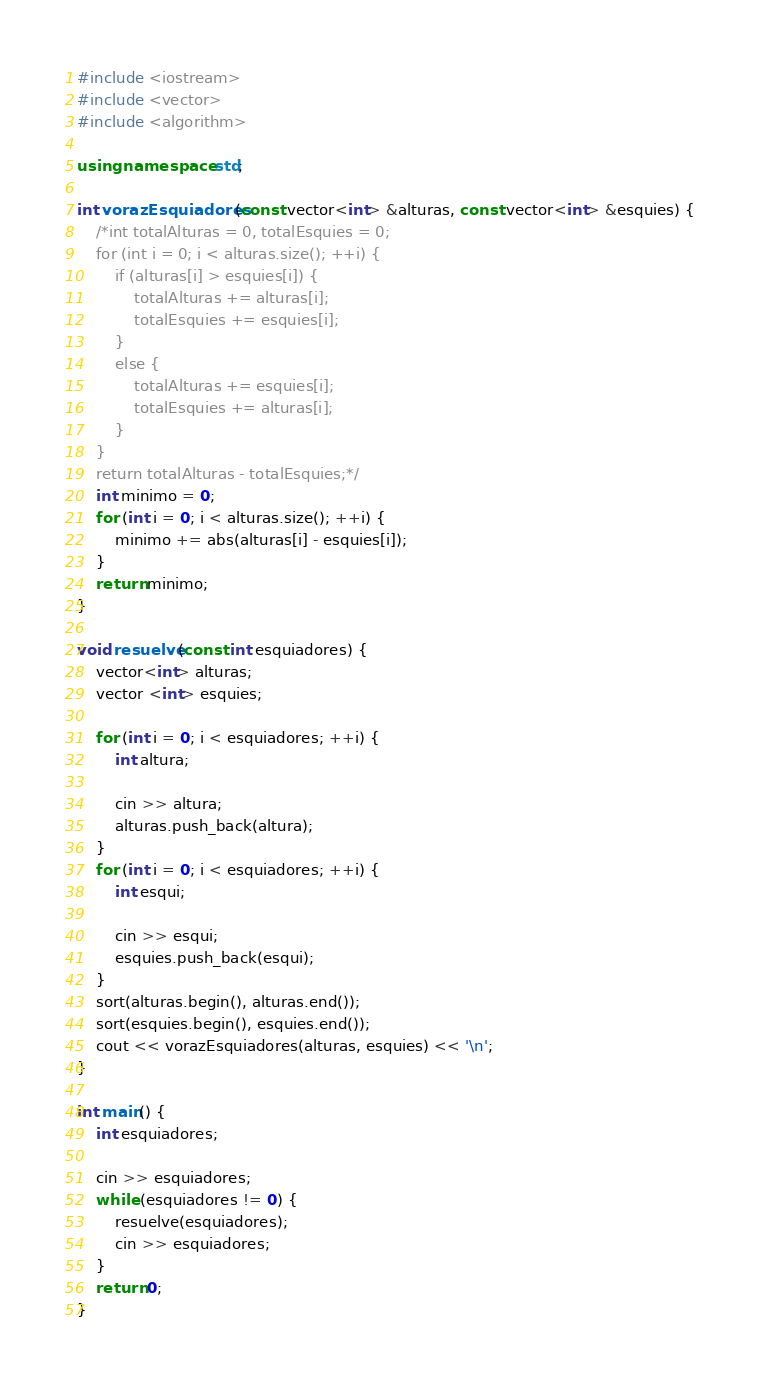Convert code to text. <code><loc_0><loc_0><loc_500><loc_500><_C++_>#include <iostream>
#include <vector>
#include <algorithm>

using namespace std;

int vorazEsquiadores(const vector<int> &alturas, const vector<int> &esquies) {
	/*int totalAlturas = 0, totalEsquies = 0;
	for (int i = 0; i < alturas.size(); ++i) {
		if (alturas[i] > esquies[i]) {
			totalAlturas += alturas[i];
			totalEsquies += esquies[i];
		}
		else {
			totalAlturas += esquies[i];
			totalEsquies += alturas[i];
		}
	}
	return totalAlturas - totalEsquies;*/
	int minimo = 0;
	for (int i = 0; i < alturas.size(); ++i) {
		minimo += abs(alturas[i] - esquies[i]);
	}
	return minimo;
}

void resuelve(const int esquiadores) {
	vector<int> alturas;
	vector <int> esquies;

	for (int i = 0; i < esquiadores; ++i) {
		int altura;
		
		cin >> altura;
		alturas.push_back(altura);
	}
	for (int i = 0; i < esquiadores; ++i) {
		int esqui;

		cin >> esqui;
		esquies.push_back(esqui);
	}
	sort(alturas.begin(), alturas.end());
	sort(esquies.begin(), esquies.end());
	cout << vorazEsquiadores(alturas, esquies) << '\n';
}

int main() {
	int esquiadores;

	cin >> esquiadores;
	while (esquiadores != 0) {
		resuelve(esquiadores);
		cin >> esquiadores;
	}
	return 0;
}</code> 